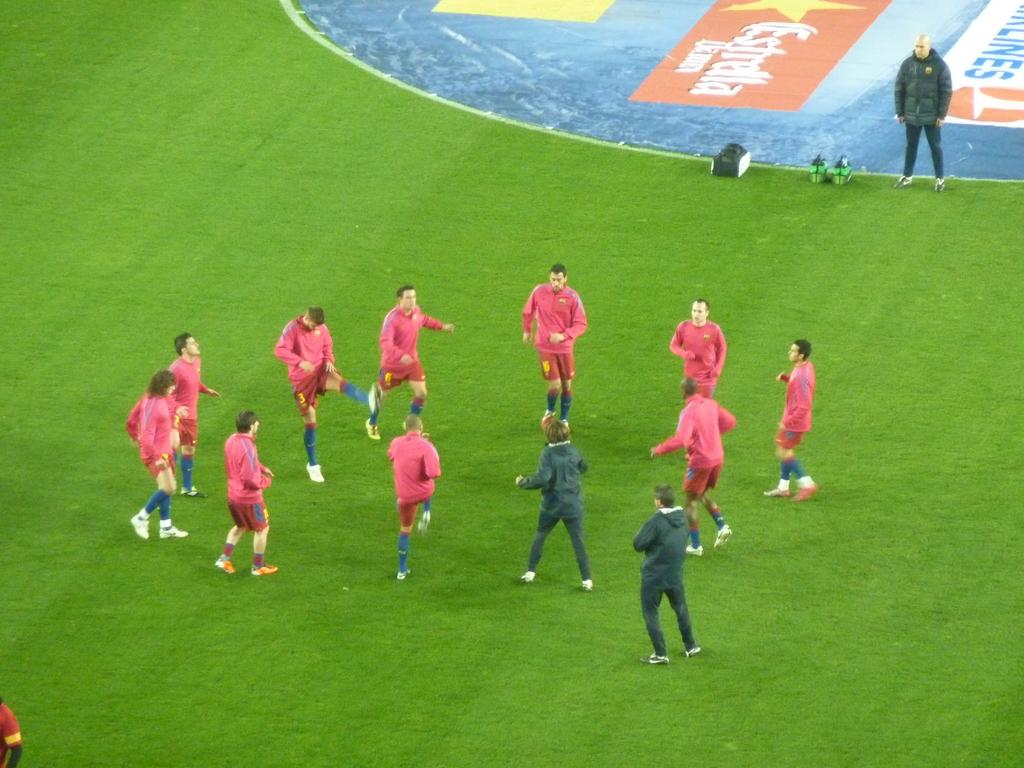Who or what can be seen in the image? There are people in the image. What object is on the ground in the image? There is a bag on the ground. What type of artwork is present in the image? There is a painting in the image. What is written or drawn on the ground in the image? There is text on the ground. What type of cart can be seen carrying a ship in the image? There is no cart or ship present in the image. 